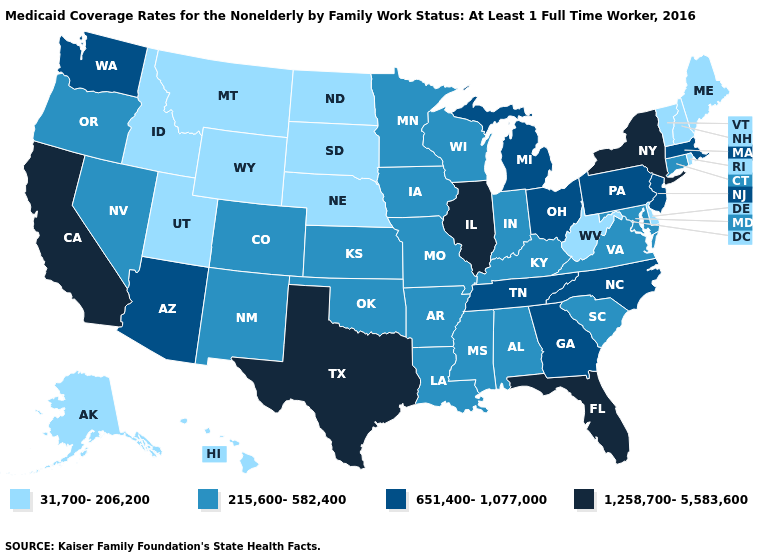What is the lowest value in the USA?
Give a very brief answer. 31,700-206,200. Which states have the highest value in the USA?
Short answer required. California, Florida, Illinois, New York, Texas. Name the states that have a value in the range 31,700-206,200?
Give a very brief answer. Alaska, Delaware, Hawaii, Idaho, Maine, Montana, Nebraska, New Hampshire, North Dakota, Rhode Island, South Dakota, Utah, Vermont, West Virginia, Wyoming. Which states have the lowest value in the USA?
Quick response, please. Alaska, Delaware, Hawaii, Idaho, Maine, Montana, Nebraska, New Hampshire, North Dakota, Rhode Island, South Dakota, Utah, Vermont, West Virginia, Wyoming. How many symbols are there in the legend?
Be succinct. 4. Name the states that have a value in the range 651,400-1,077,000?
Write a very short answer. Arizona, Georgia, Massachusetts, Michigan, New Jersey, North Carolina, Ohio, Pennsylvania, Tennessee, Washington. Name the states that have a value in the range 1,258,700-5,583,600?
Short answer required. California, Florida, Illinois, New York, Texas. What is the highest value in the West ?
Quick response, please. 1,258,700-5,583,600. Among the states that border New Mexico , which have the highest value?
Short answer required. Texas. Name the states that have a value in the range 215,600-582,400?
Give a very brief answer. Alabama, Arkansas, Colorado, Connecticut, Indiana, Iowa, Kansas, Kentucky, Louisiana, Maryland, Minnesota, Mississippi, Missouri, Nevada, New Mexico, Oklahoma, Oregon, South Carolina, Virginia, Wisconsin. Does New York have the highest value in the Northeast?
Write a very short answer. Yes. Does Maine have a lower value than Hawaii?
Short answer required. No. What is the value of California?
Be succinct. 1,258,700-5,583,600. Does New Jersey have the lowest value in the USA?
Give a very brief answer. No. Name the states that have a value in the range 31,700-206,200?
Answer briefly. Alaska, Delaware, Hawaii, Idaho, Maine, Montana, Nebraska, New Hampshire, North Dakota, Rhode Island, South Dakota, Utah, Vermont, West Virginia, Wyoming. 